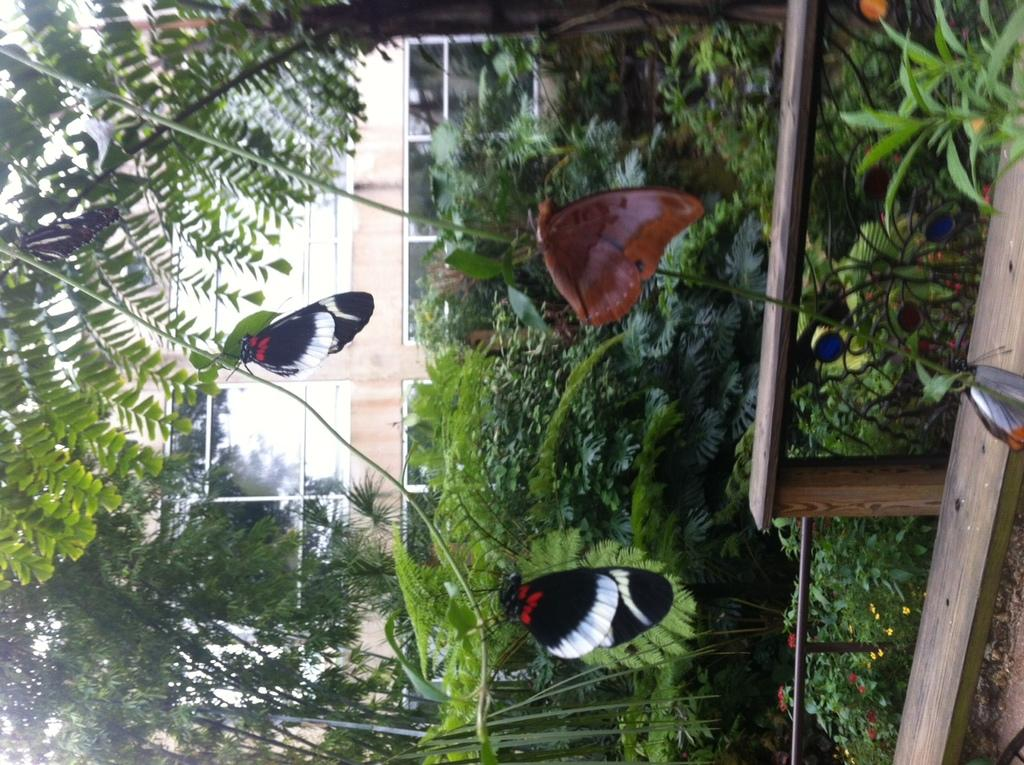What type of animals can be seen in the image? There are butterflies in the image. What is the color of the objects behind the butterflies? The butterflies are in front of green color things. What can be seen in the background of the image? There are plants, trees, and a building in the background of the image. What type of blood can be seen flowing from the basin in the image? There is no blood or basin present in the image. 